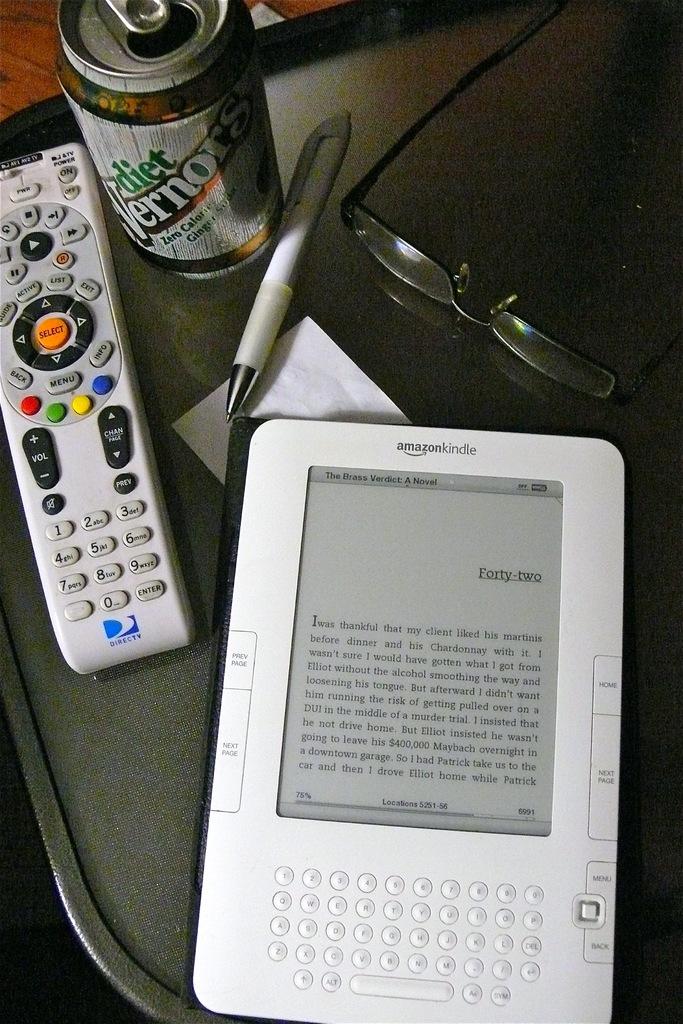What's on the soda can?
Give a very brief answer. Diet vernors. 